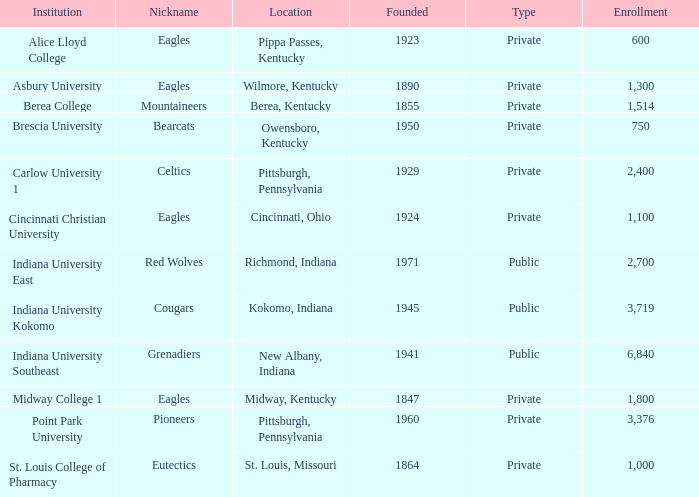Which of the private educational institutions is the most ancient, and whose moniker is the mountaineers? 1855.0. 